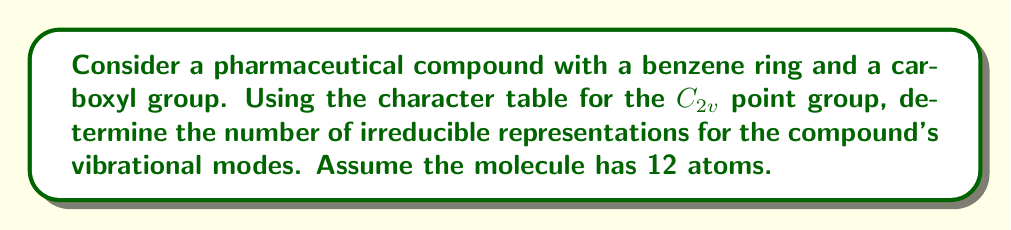Help me with this question. To solve this problem, we'll follow these steps:

1) First, recall that for a molecule with N atoms, the total number of vibrational modes is $3N - 6$ for non-linear molecules.

2) Our compound has 12 atoms, so:
   $3N - 6 = 3(12) - 6 = 36 - 6 = 30$ vibrational modes

3) The $C_{2v}$ point group has four irreducible representations: $A_1$, $A_2$, $B_1$, and $B_2$.

4) To determine how many modes belong to each irreducible representation, we use the reduction formula:

   $n_i = \frac{1}{h} \sum_R \chi^{(i)}(R) \chi^{(\Gamma)}(R)$

   where $n_i$ is the number of times the $i$-th irreducible representation appears, $h$ is the order of the group, $\chi^{(i)}(R)$ is the character of the $i$-th irreducible representation for operation $R$, and $\chi^{(\Gamma)}(R)$ is the character of the reducible representation for operation $R$.

5) For vibrational modes, the characters of the reducible representation are:
   $\chi^{(\Gamma)}(E) = 3N - 3 = 33$
   $\chi^{(\Gamma)}(C_2) = -1$
   $\chi^{(\Gamma)}(\sigma_v(xz)) = \chi^{(\Gamma)}(\sigma_v(yz)) = 1$

6) Applying the reduction formula for each irreducible representation:

   $n_{A_1} = \frac{1}{4}[(1)(33) + (1)(-1) + (1)(1) + (1)(1)] = \frac{34}{4} = 8.5$
   $n_{A_2} = \frac{1}{4}[(1)(33) + (1)(-1) + (-1)(1) + (-1)(1)] = \frac{30}{4} = 7.5$
   $n_{B_1} = \frac{1}{4}[(1)(33) + (-1)(-1) + (1)(1) + (-1)(1)] = \frac{34}{4} = 8.5$
   $n_{B_2} = \frac{1}{4}[(1)(33) + (-1)(-1) + (-1)(1) + (1)(1)] = \frac{32}{4} = 8$

7) Rounding to whole numbers (as fractional modes are not physically meaningful):
   $A_1: 9$, $A_2: 7$, $B_1: 9$, $B_2: 8$

8) The total sum is indeed 33, which matches our expectation of 30 vibrational modes plus 3 rotational modes.
Answer: $A_1: 9$, $A_2: 7$, $B_1: 9$, $B_2: 8$ 